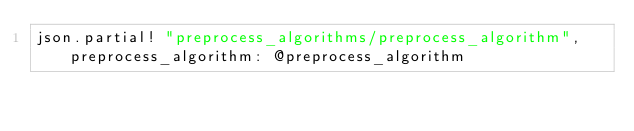<code> <loc_0><loc_0><loc_500><loc_500><_Ruby_>json.partial! "preprocess_algorithms/preprocess_algorithm", preprocess_algorithm: @preprocess_algorithm
</code> 